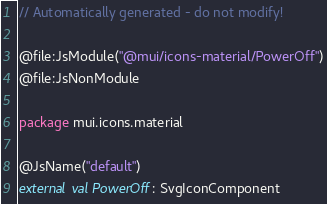<code> <loc_0><loc_0><loc_500><loc_500><_Kotlin_>// Automatically generated - do not modify!

@file:JsModule("@mui/icons-material/PowerOff")
@file:JsNonModule

package mui.icons.material

@JsName("default")
external val PowerOff: SvgIconComponent
</code> 